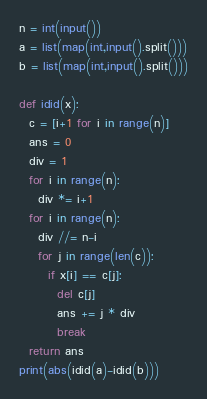<code> <loc_0><loc_0><loc_500><loc_500><_Python_>n = int(input())
a = list(map(int,input().split()))
b = list(map(int,input().split()))

def idid(x):
  c = [i+1 for i in range(n)]
  ans = 0
  div = 1
  for i in range(n):
    div *= i+1
  for i in range(n):
    div //= n-i
    for j in range(len(c)):
      if x[i] == c[j]:
        del c[j]
        ans += j * div
        break
  return ans
print(abs(idid(a)-idid(b)))</code> 